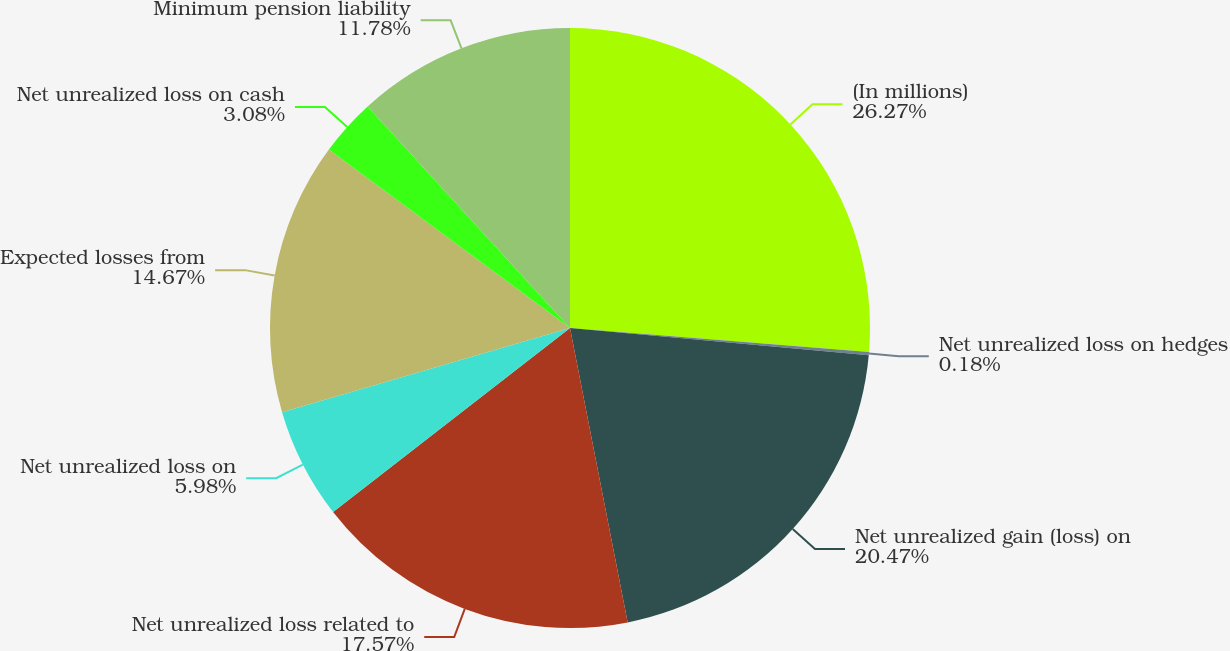Convert chart to OTSL. <chart><loc_0><loc_0><loc_500><loc_500><pie_chart><fcel>(In millions)<fcel>Net unrealized loss on hedges<fcel>Net unrealized gain (loss) on<fcel>Net unrealized loss related to<fcel>Net unrealized loss on<fcel>Expected losses from<fcel>Net unrealized loss on cash<fcel>Minimum pension liability<nl><fcel>26.27%<fcel>0.18%<fcel>20.47%<fcel>17.57%<fcel>5.98%<fcel>14.67%<fcel>3.08%<fcel>11.78%<nl></chart> 